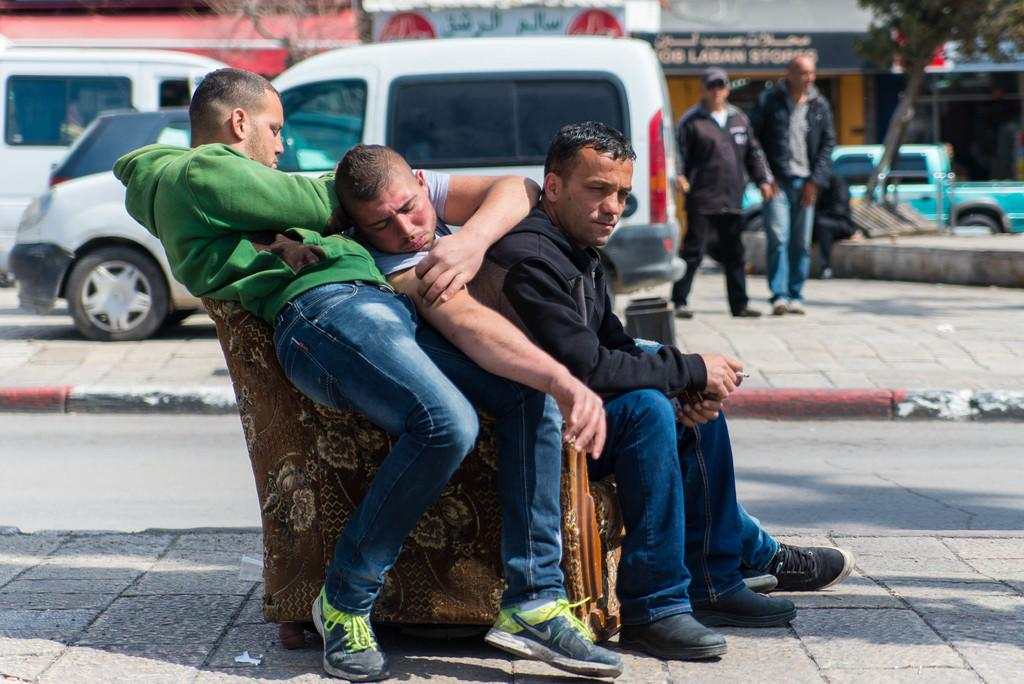How many men are in the image? There are three men in the image. What are the men doing in the image? The men are sitting on a chair. Where is the chair located in the image? The chair is on a path. What can be seen in the background of the image? People, vehicles, trees, and boards are visible in the background of the image. Reasoning: Let' Let's think step by step in order to produce the conversation. We start by identifying the main subjects in the image, which are the three men. Then, we describe their actions and location, noting that they are sitting on a chair on a path. Finally, we expand the conversation to include the background of the image, mentioning the presence of people, vehicles, trees, and boards. Absurd Question/Answer: What type of caption is written on the boards in the image? There is no caption visible on the boards in the image. How does the fan affect the men sitting on the chair in the image? There is no fan present in the image; the men are sitting on a chair without any visible fan. 